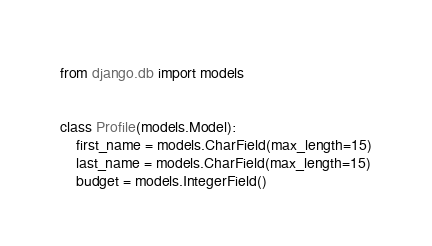Convert code to text. <code><loc_0><loc_0><loc_500><loc_500><_Python_>from django.db import models


class Profile(models.Model):
    first_name = models.CharField(max_length=15)
    last_name = models.CharField(max_length=15)
    budget = models.IntegerField()

</code> 